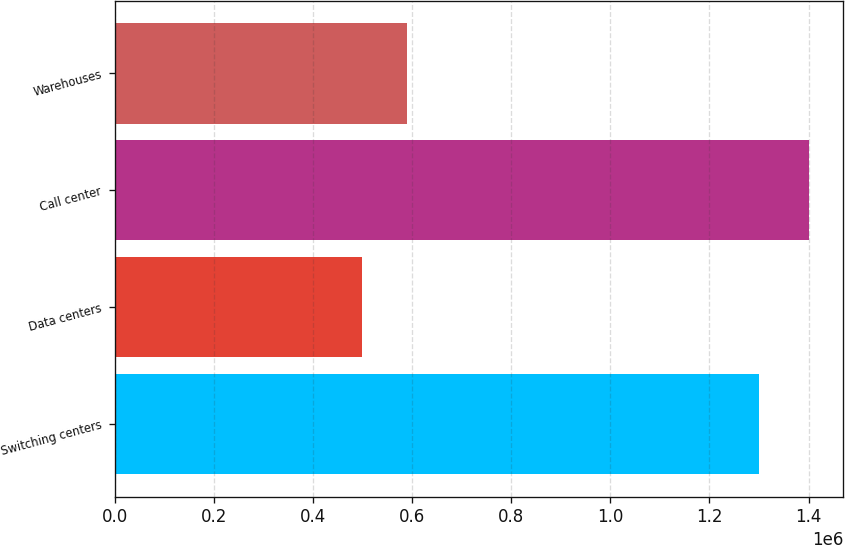Convert chart to OTSL. <chart><loc_0><loc_0><loc_500><loc_500><bar_chart><fcel>Switching centers<fcel>Data centers<fcel>Call center<fcel>Warehouses<nl><fcel>1.3e+06<fcel>500000<fcel>1.4e+06<fcel>590000<nl></chart> 